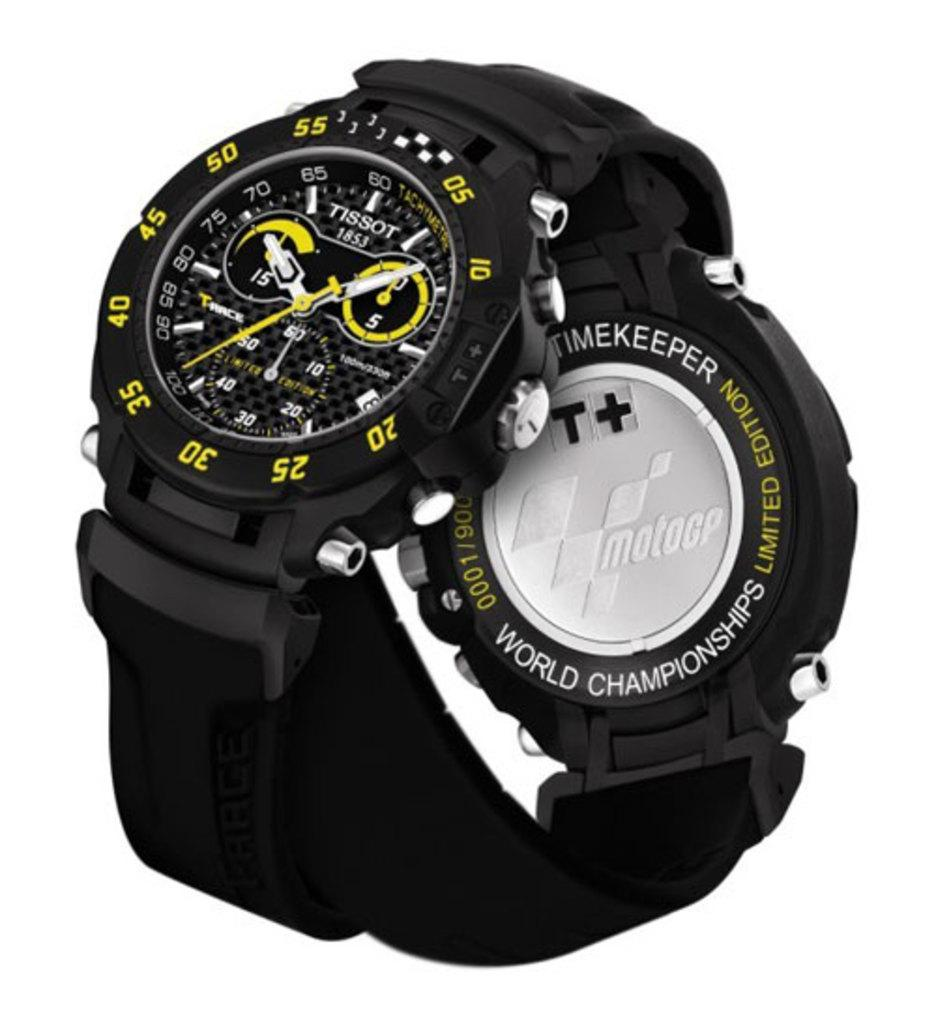What type of object is the main subject of the image? The main subject of the image is a watch. What is the color of the watch? The watch is black in color. Are there any numbers on the watch? Yes, there are yellow color numbers on the border of the watch. What is the color of the background in the image? The background of the image is white in color. Reasoning: Let' Let's think step by step in order to produce the conversation. We start by identifying the main subject of the image, which is a watch. Then, we describe the color of the watch and mention the presence of yellow numbers on its border. Finally, we describe the color of the background, which is white. Each question is designed to elicit a specific detail about the image that is known from the provided facts. Absurd Question/Answer: What type of learning material is present in the image? There is no learning material or book present in the image; it features a black watch with yellow numbers on a white background. Can you see a duck in the image? There is no duck present in the image. What type of learning material is present in the image? There is no learning material or book present in the image; it features a black watch with yellow numbers on a white background. Can you see a duck in the image? There is no duck present in the image. 